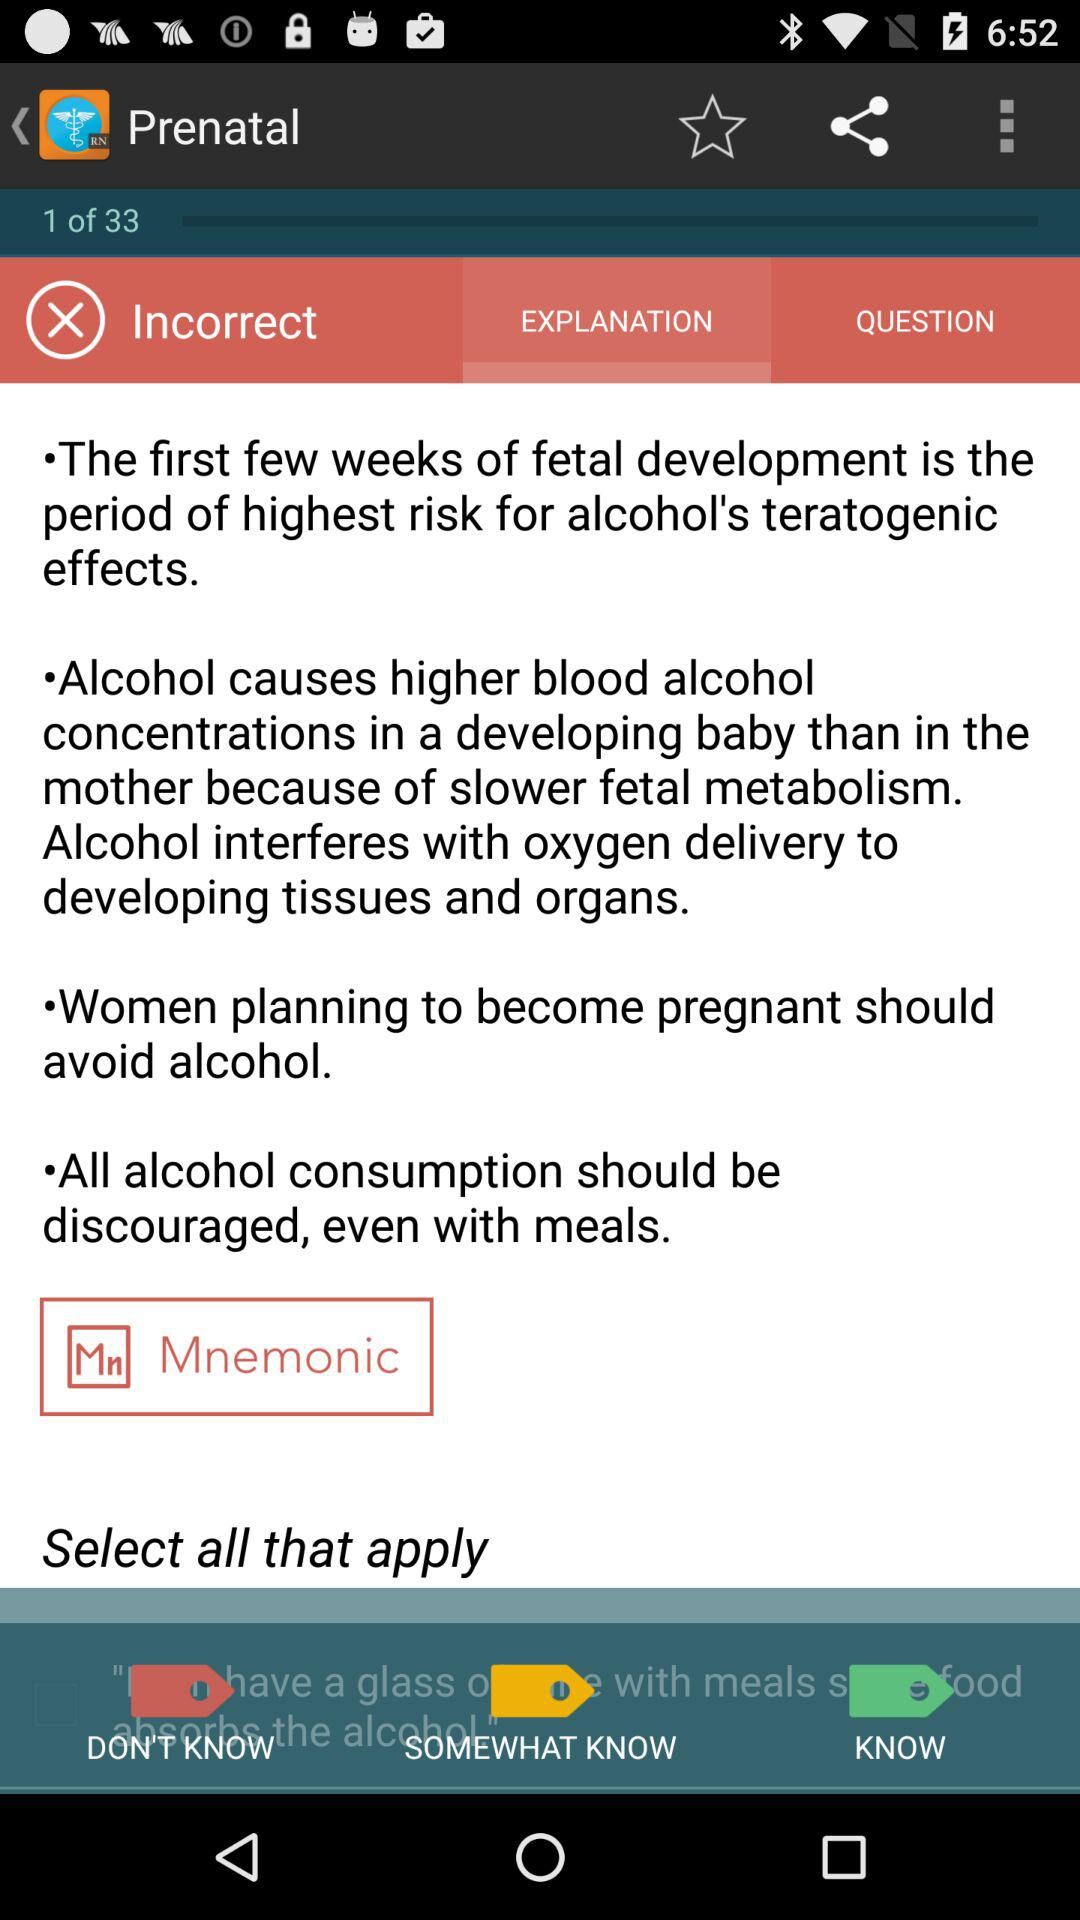How many tags are green or somewhat know?
Answer the question using a single word or phrase. 2 